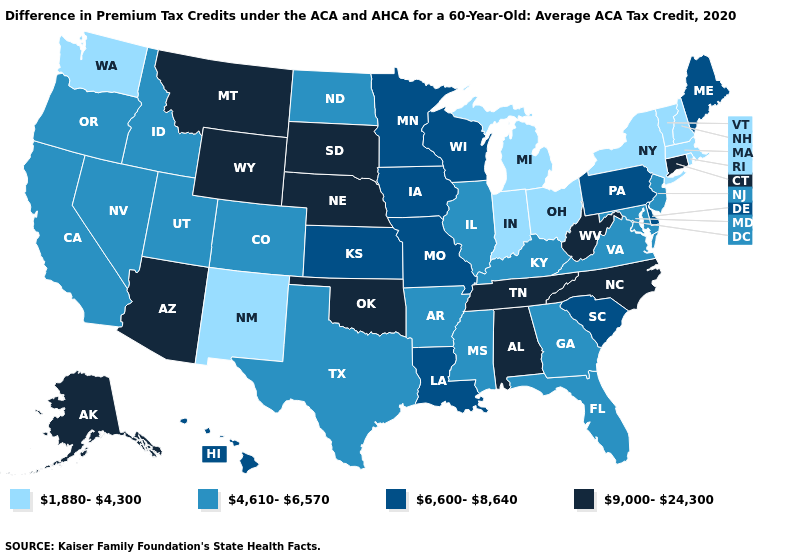Among the states that border Oregon , does Washington have the lowest value?
Keep it brief. Yes. Name the states that have a value in the range 4,610-6,570?
Be succinct. Arkansas, California, Colorado, Florida, Georgia, Idaho, Illinois, Kentucky, Maryland, Mississippi, Nevada, New Jersey, North Dakota, Oregon, Texas, Utah, Virginia. Among the states that border Washington , which have the highest value?
Be succinct. Idaho, Oregon. Does the map have missing data?
Short answer required. No. Among the states that border New Mexico , which have the highest value?
Short answer required. Arizona, Oklahoma. Which states have the lowest value in the West?
Write a very short answer. New Mexico, Washington. Among the states that border Vermont , which have the highest value?
Give a very brief answer. Massachusetts, New Hampshire, New York. What is the lowest value in states that border Kentucky?
Write a very short answer. 1,880-4,300. Among the states that border Delaware , which have the highest value?
Short answer required. Pennsylvania. What is the lowest value in states that border Florida?
Concise answer only. 4,610-6,570. Does North Carolina have the highest value in the USA?
Be succinct. Yes. How many symbols are there in the legend?
Be succinct. 4. Name the states that have a value in the range 9,000-24,300?
Answer briefly. Alabama, Alaska, Arizona, Connecticut, Montana, Nebraska, North Carolina, Oklahoma, South Dakota, Tennessee, West Virginia, Wyoming. Name the states that have a value in the range 9,000-24,300?
Quick response, please. Alabama, Alaska, Arizona, Connecticut, Montana, Nebraska, North Carolina, Oklahoma, South Dakota, Tennessee, West Virginia, Wyoming. 